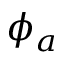Convert formula to latex. <formula><loc_0><loc_0><loc_500><loc_500>\phi _ { a }</formula> 